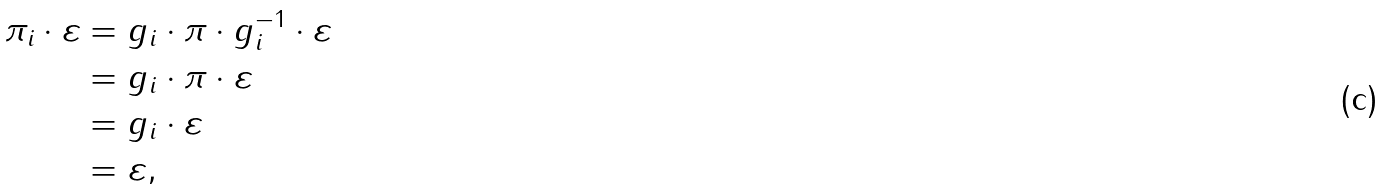Convert formula to latex. <formula><loc_0><loc_0><loc_500><loc_500>\pi _ { i } \cdot \varepsilon & = g _ { i } \cdot \pi \cdot g _ { i } ^ { - 1 } \cdot \varepsilon \\ & = g _ { i } \cdot \pi \cdot \varepsilon \\ & = g _ { i } \cdot \varepsilon \\ & = \varepsilon ,</formula> 